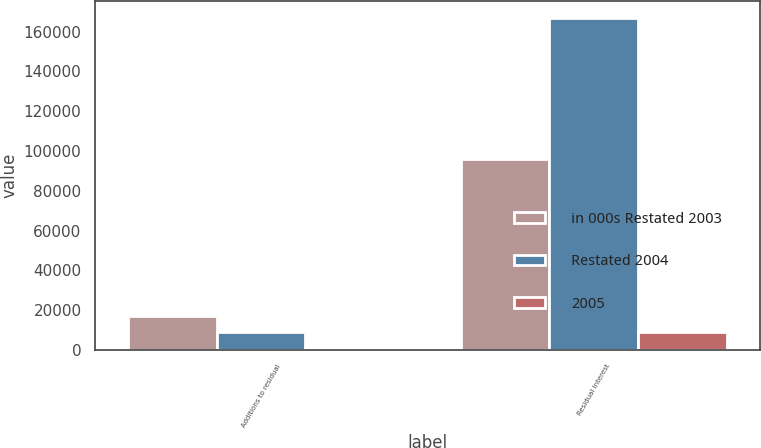Convert chart. <chart><loc_0><loc_0><loc_500><loc_500><stacked_bar_chart><ecel><fcel>Additions to residual<fcel>Residual interest<nl><fcel>in 000s Restated 2003<fcel>16914<fcel>95929<nl><fcel>Restated 2004<fcel>9007<fcel>167065<nl><fcel>2005<fcel>753<fcel>9176<nl></chart> 